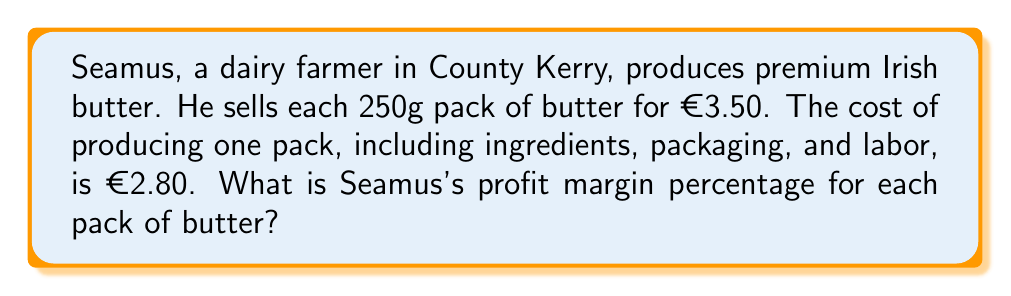Provide a solution to this math problem. To calculate the profit margin percentage, we need to follow these steps:

1. Calculate the profit per pack:
   Profit = Selling price - Cost
   $$ \text{Profit} = €3.50 - €2.80 = €0.70 $$

2. Calculate the profit margin as a decimal:
   Profit margin (decimal) = Profit ÷ Selling price
   $$ \text{Profit margin (decimal)} = \frac{€0.70}{€3.50} = 0.20 $$

3. Convert the decimal to a percentage:
   Profit margin (%) = Profit margin (decimal) × 100
   $$ \text{Profit margin (%)} = 0.20 \times 100 = 20\% $$

Therefore, Seamus's profit margin percentage for each pack of butter is 20%.
Answer: 20% 